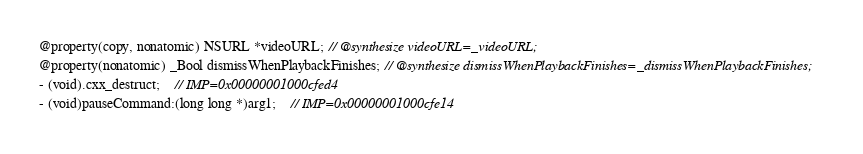<code> <loc_0><loc_0><loc_500><loc_500><_C_>@property(copy, nonatomic) NSURL *videoURL; // @synthesize videoURL=_videoURL;
@property(nonatomic) _Bool dismissWhenPlaybackFinishes; // @synthesize dismissWhenPlaybackFinishes=_dismissWhenPlaybackFinishes;
- (void).cxx_destruct;	// IMP=0x00000001000cfed4
- (void)pauseCommand:(long long *)arg1;	// IMP=0x00000001000cfe14</code> 